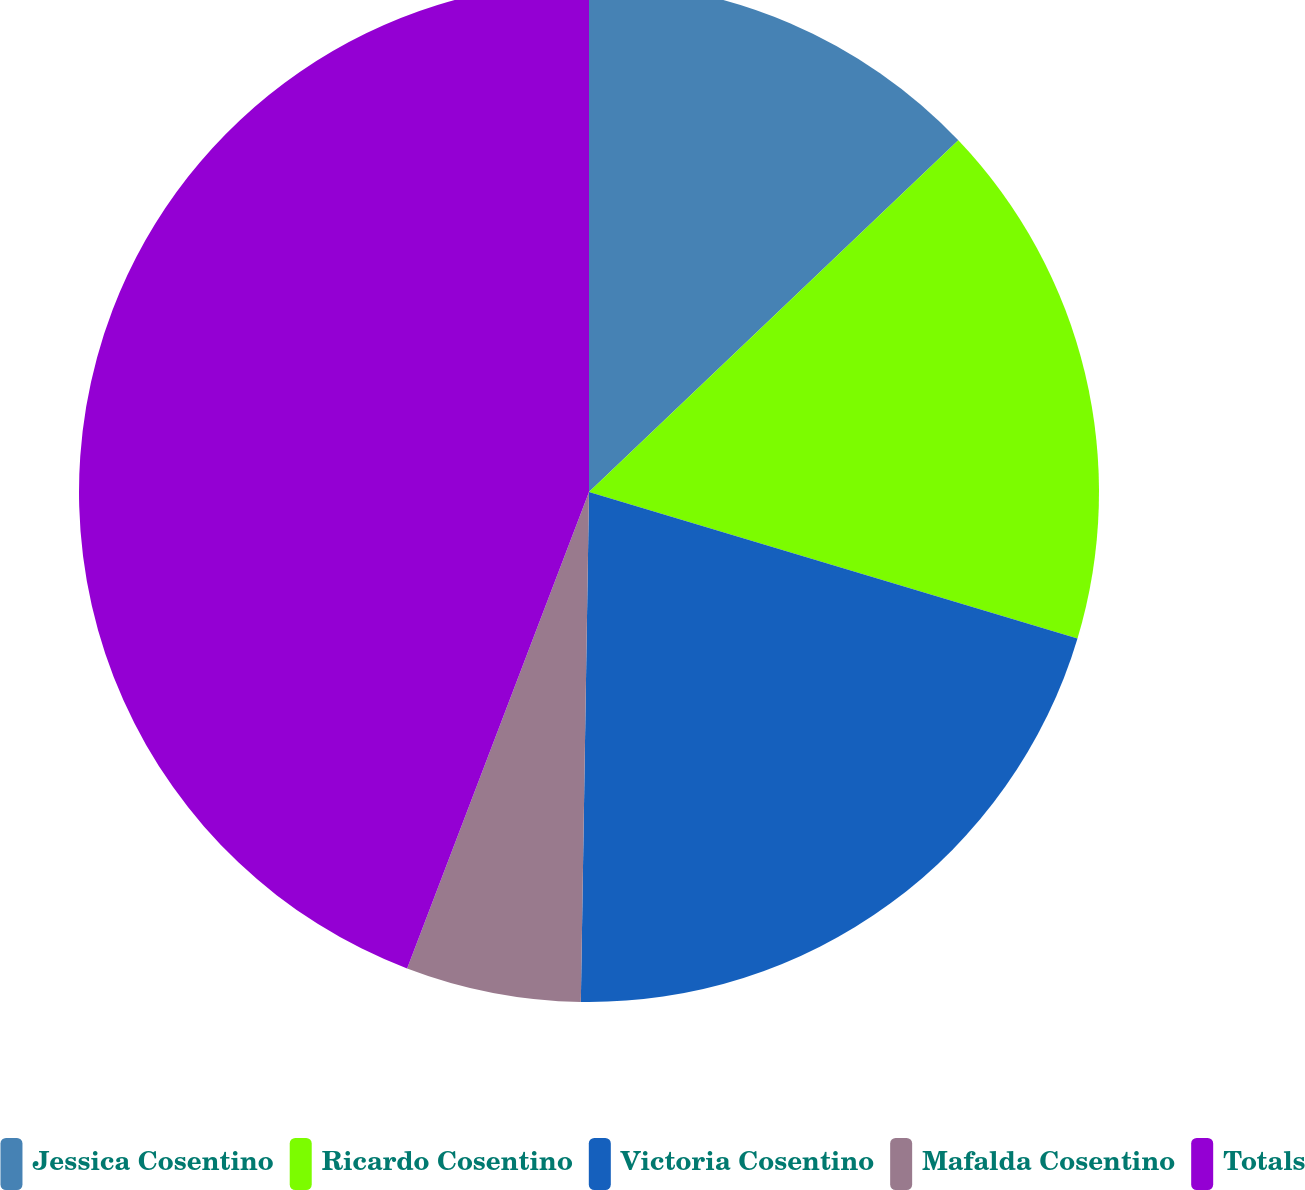<chart> <loc_0><loc_0><loc_500><loc_500><pie_chart><fcel>Jessica Cosentino<fcel>Ricardo Cosentino<fcel>Victoria Cosentino<fcel>Mafalda Cosentino<fcel>Totals<nl><fcel>12.89%<fcel>16.75%<fcel>20.62%<fcel>5.55%<fcel>44.2%<nl></chart> 